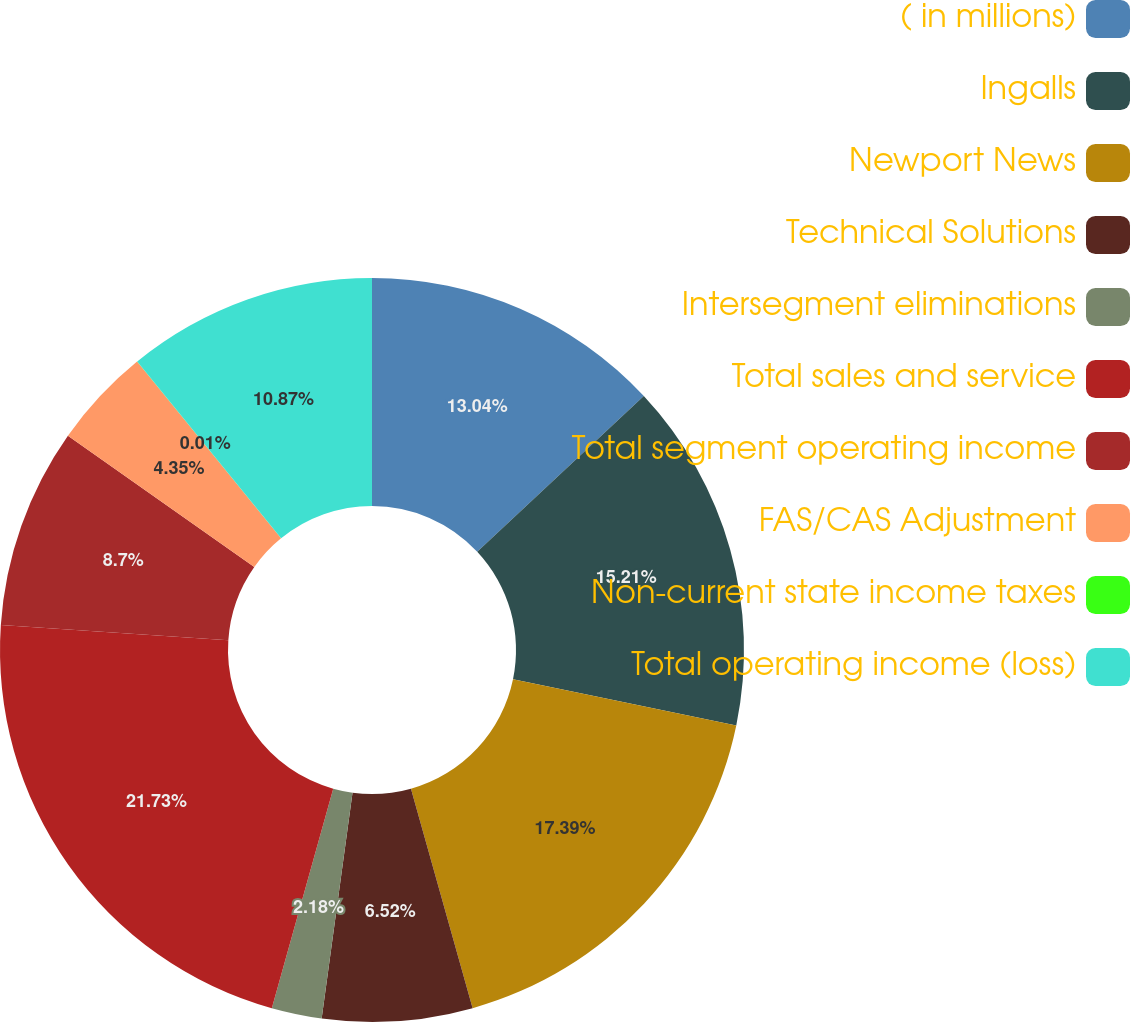Convert chart to OTSL. <chart><loc_0><loc_0><loc_500><loc_500><pie_chart><fcel>( in millions)<fcel>Ingalls<fcel>Newport News<fcel>Technical Solutions<fcel>Intersegment eliminations<fcel>Total sales and service<fcel>Total segment operating income<fcel>FAS/CAS Adjustment<fcel>Non-current state income taxes<fcel>Total operating income (loss)<nl><fcel>13.04%<fcel>15.21%<fcel>17.39%<fcel>6.52%<fcel>2.18%<fcel>21.73%<fcel>8.7%<fcel>4.35%<fcel>0.01%<fcel>10.87%<nl></chart> 